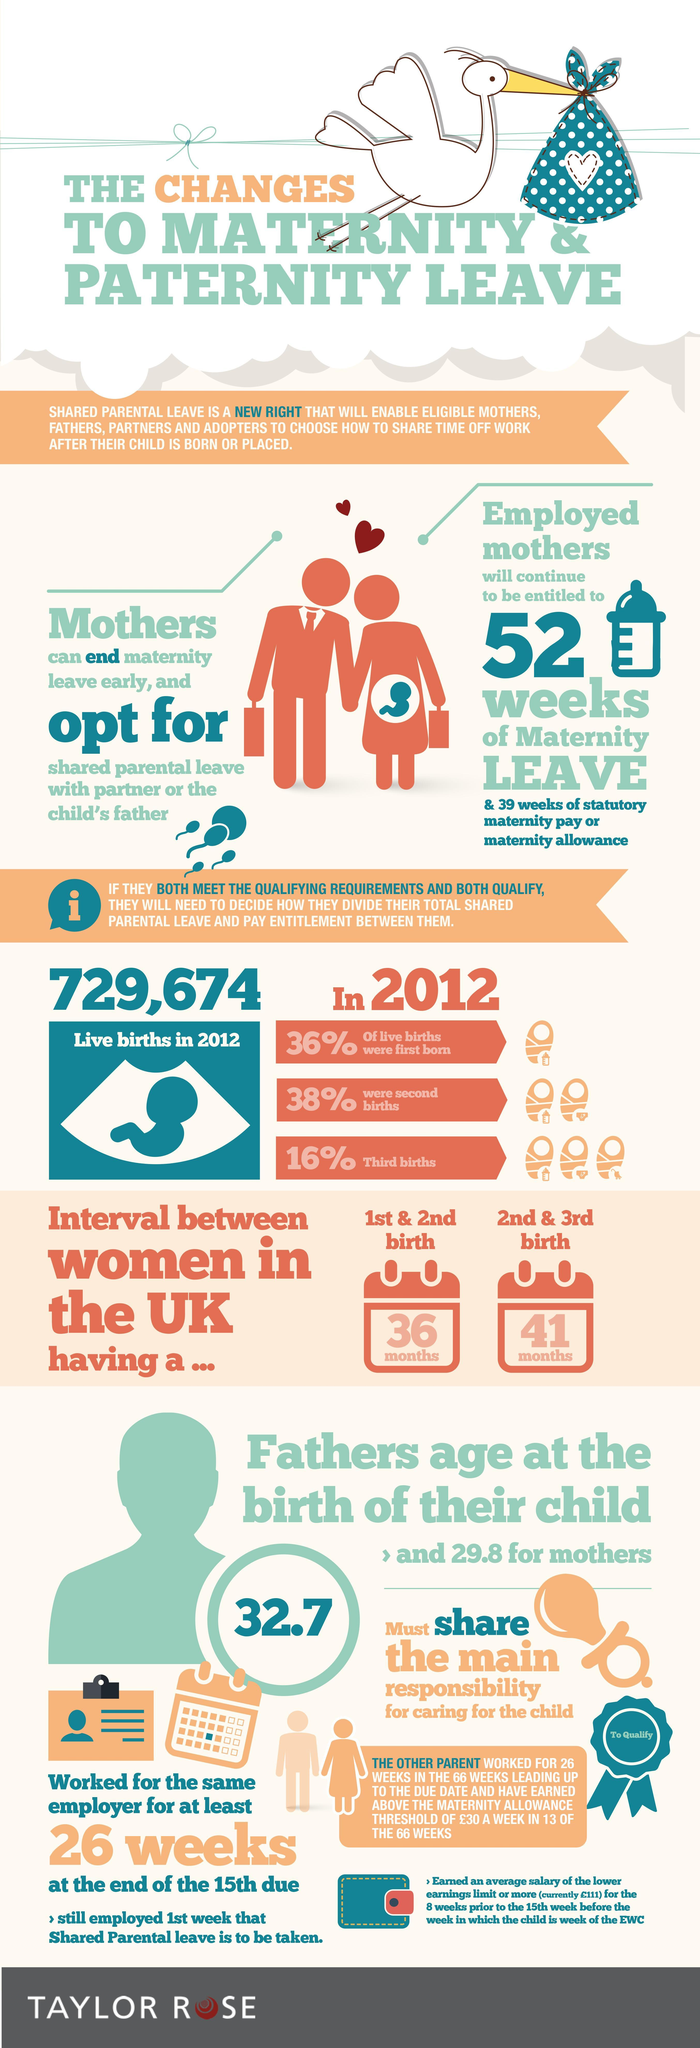What is the average age of the father at the birth of their child?
Answer the question with a short phrase. 32.7 What percentage of live births was first bon in 2012? 36% Which was the highest in live births in 2012, first born, second births or third births? second births What is the average age of the mother at the birth of their child? 29.8 